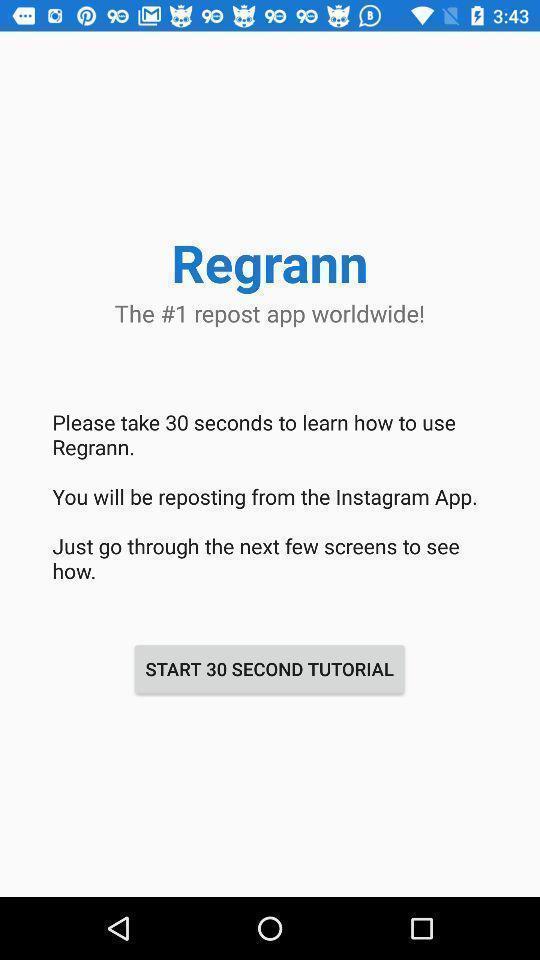Give me a summary of this screen capture. Welcome page for a repost app. 